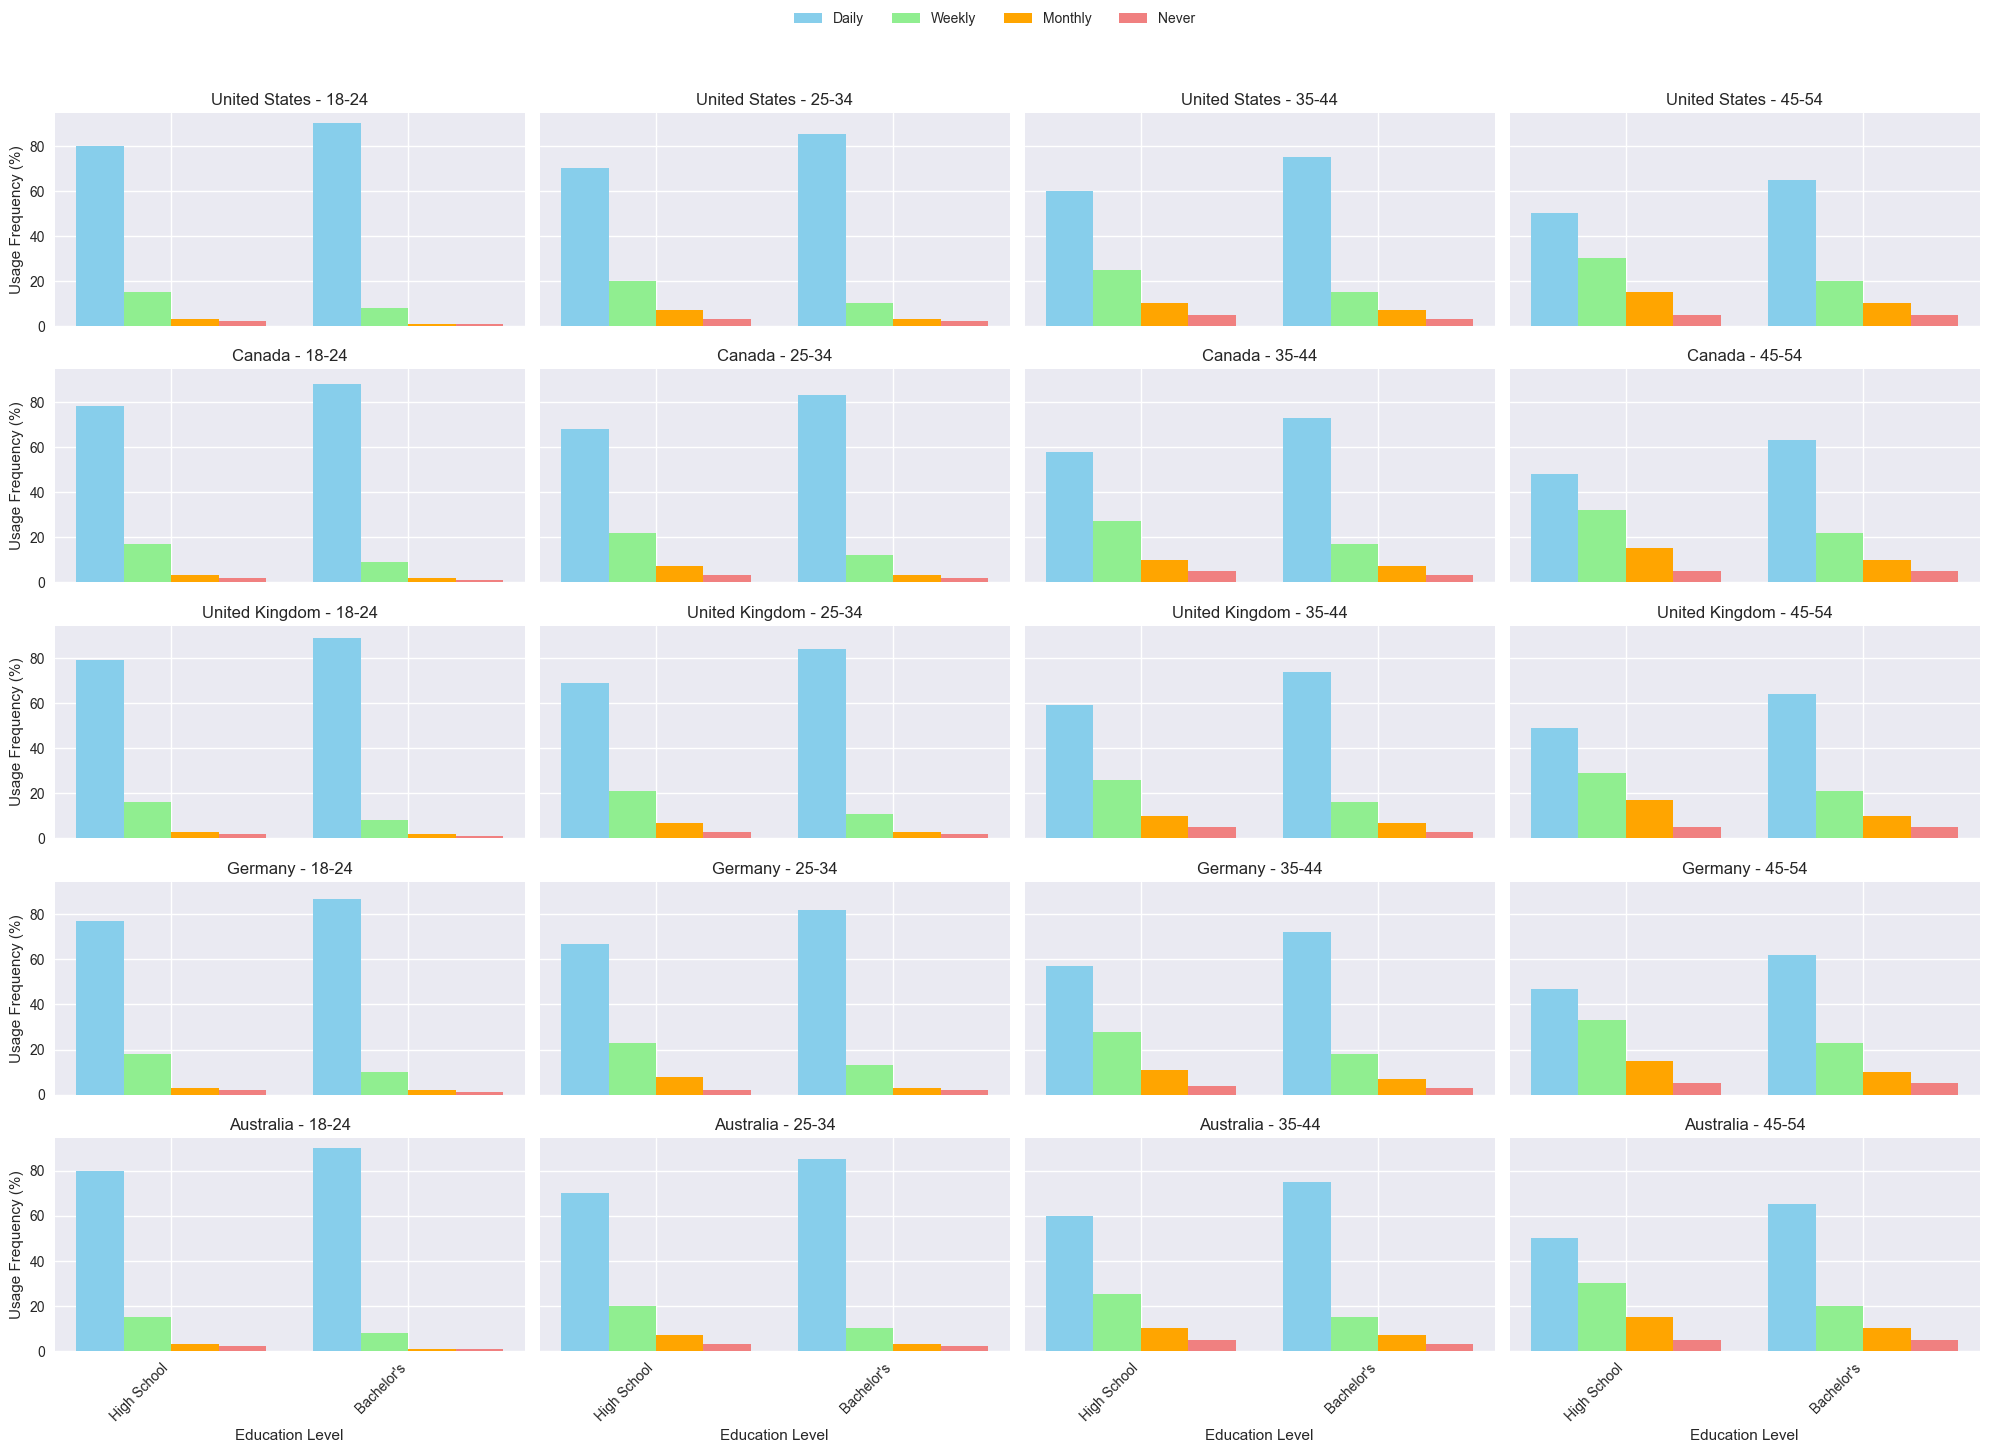Which age group in the United States with a High School education uses the internet daily the most? Observe the bars for the daily internet usage in the United States for different age groups with a High School education. The 18-24 group has the tallest bar at 80%, indicating the highest daily usage.
Answer: 18-24 How does weekly internet usage for Canadians age 25-34 with a Bachelor's degree compare to those with a High School education? Compare the weekly usage bars for age group 25-34 in Canada between Bachelor's and High School education levels. Bachelor's degree has a shorter bar (12%) compared to High School (22%), indicating less weekly usage for those with a Bachelor's degree.
Answer: Higher for High School What is the average monthly internet usage for the 35-44 age group in the United Kingdom with High School and Bachelor’s education levels combined? To find the average, sum the monthly usage percentages for both education levels and divide by 2. For High School (10%) and Bachelor’s (7%), the sum is 17%. Average = 17/2 = 8.5%.
Answer: 8.5% Which nation has the highest percentage of people who never use the internet in the 45-54 age group with a High School education? Compare the 'Never' usage bars across the nations for the 45-54 age group with a High School education. Germany has a 5% bar for this category, which is the highest among the nations.
Answer: Germany Is there any age group in Australia where internet usage daily percentage for High School education level equals Bachelor’s education level? Compare the height of daily usage bars for each age group in Australia between High School and Bachelor’s education levels. There is no age group with equal usage; each Bachelor’s group has a higher percentage.
Answer: No Which education level in the 25-34 age group in Germany has a higher combined percentage of daily and weekly internet usage? Add the daily and weekly percentages for each education level in the 25-34 age group in Germany. High School is 67% + 23% = 90%, and Bachelor’s is 82% + 13% = 95%, making Bachelor's higher (95%).
Answer: Bachelor's Between which age groups does Australia show the largest drop in daily internet usage for those with a High School education? Compare the differences in daily usage bars between consecutive age groups for High School education. The largest drop is between 18-24 (80%) and 25-34 (70%), which is 10%.
Answer: 18-24 to 25-34 In the United States, which education level shows a greater decline in weekly internet usage as people age from 18-24 to 45-54? Calculate the decline in weekly usage for both education levels: High School goes from 15% to 30%, an increase of 15%, while Bachelor's goes from 8% to 20%, an increase of 12%. Thus, surprisingly, both increase, but High School increases more.
Answer: High School What is the difference in monthly internet usage between the youngest and oldest age groups in Canada with a Bachelor's education? Observe the monthly usage bars for the 18-24 and 45-54 age groups in Canada with a Bachelor's education; difference is 2% - 10% = -8%.
Answer: -8 Compare the never usage percentages of the 35-44 age group with a High School education across United States and United Kingdom. For the 35-44 age group with a High School education, compare the 'Never' bars: United States has 5% and United Kingdom has 5%, making them equal.
Answer: Equal 